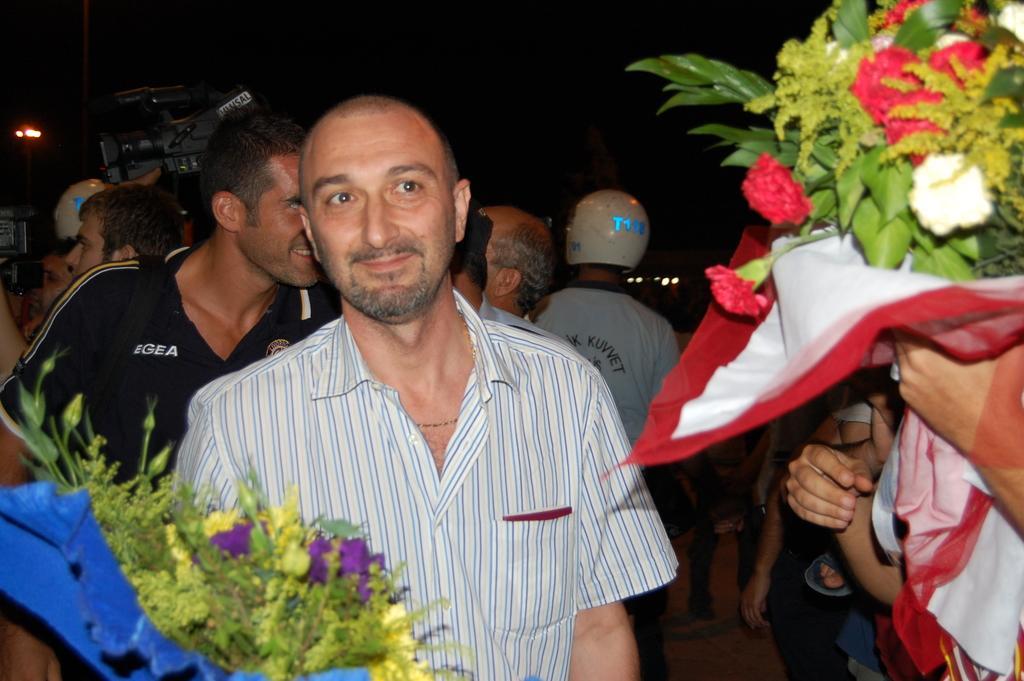In one or two sentences, can you explain what this image depicts? In this image I can see a crowd of people. Here I can see a man wearing a shirt and smiling by looking at the right side. On the right and left side of the image there are few people holding flower bouquets in the hands. The background is dark. 